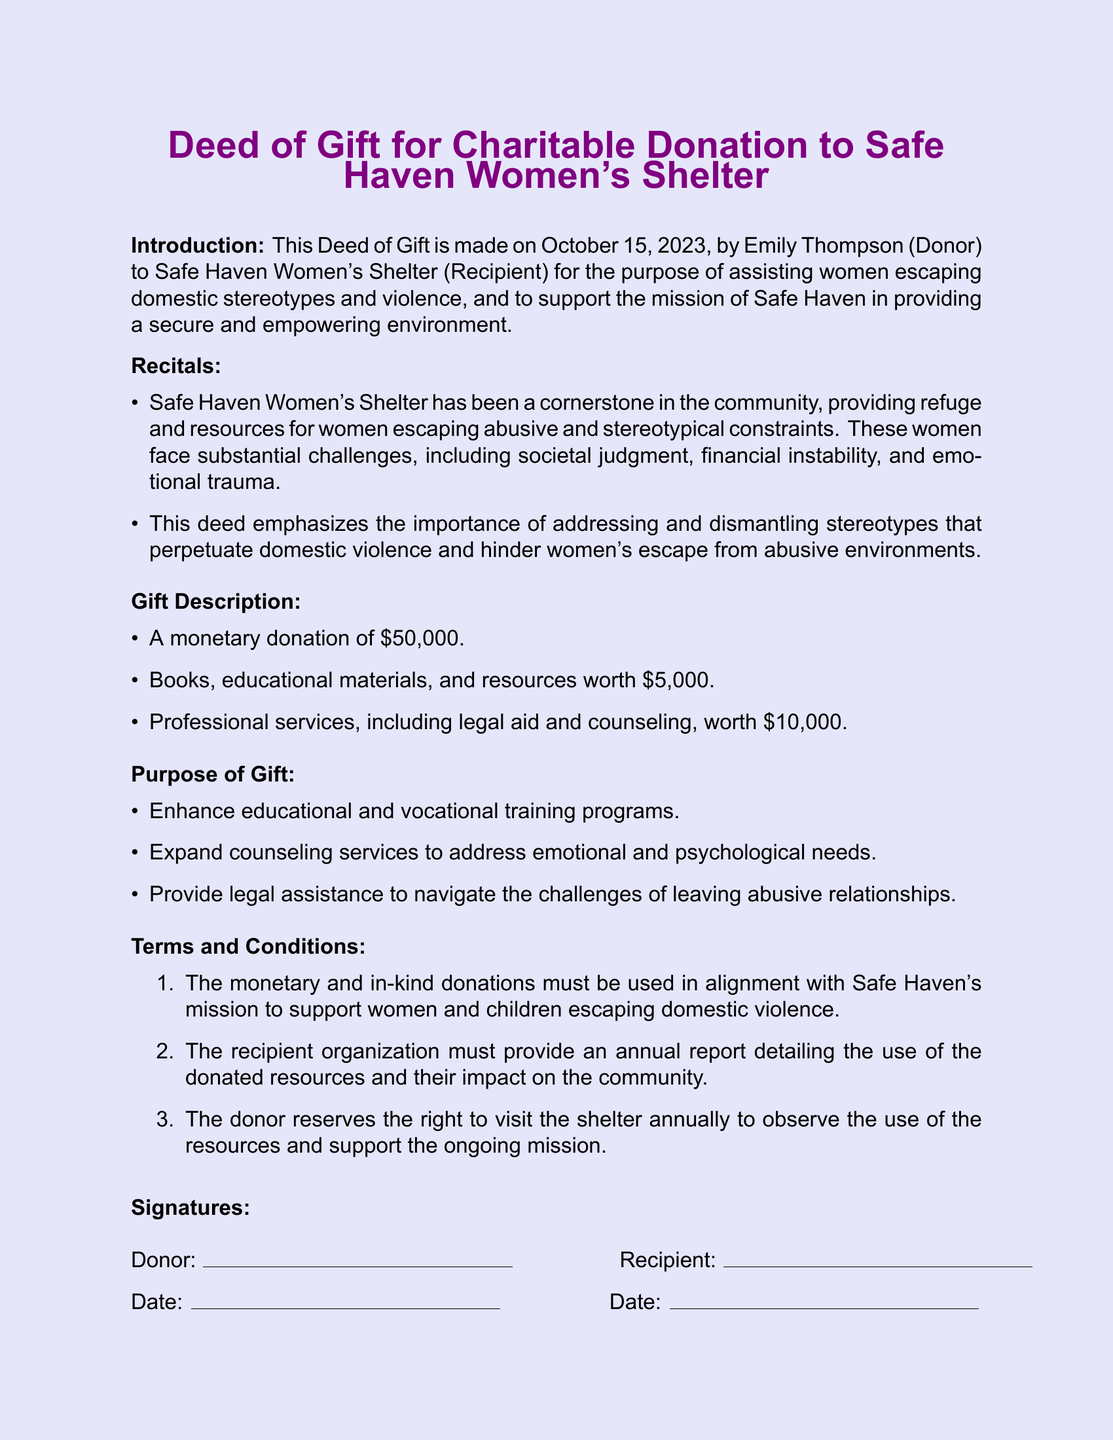What is the date of the deed? The date of the deed is mentioned in the introduction section of the document.
Answer: October 15, 2023 Who is the donor? The identity of the donor is stated at the beginning of the document.
Answer: Emily Thompson What is the total monetary donation? The total amount provided as a monetary donation is listed under the gift description.
Answer: $50,000 What type of organization is Safe Haven? The document describes Safe Haven's role in the community in the recitals section.
Answer: Women's Shelter What is one challenge faced by women mentioned in the document? The recitals section lists several challenges that women face when escaping domestic violence.
Answer: Societal judgment What must the recipient organization provide annually? This information is specified in the terms and conditions section of the document.
Answer: Annual report What is the value of the educational materials donated? The value is mentioned in the gift description, detailing the items included.
Answer: $5,000 How much is allocated for professional services? The amount designated for professional services is noted in the gift description.
Answer: $10,000 What is the primary purpose of the donation? The purposes of the gift are outlined in the purpose of gift section of the document.
Answer: Support the mission of Safe Haven 